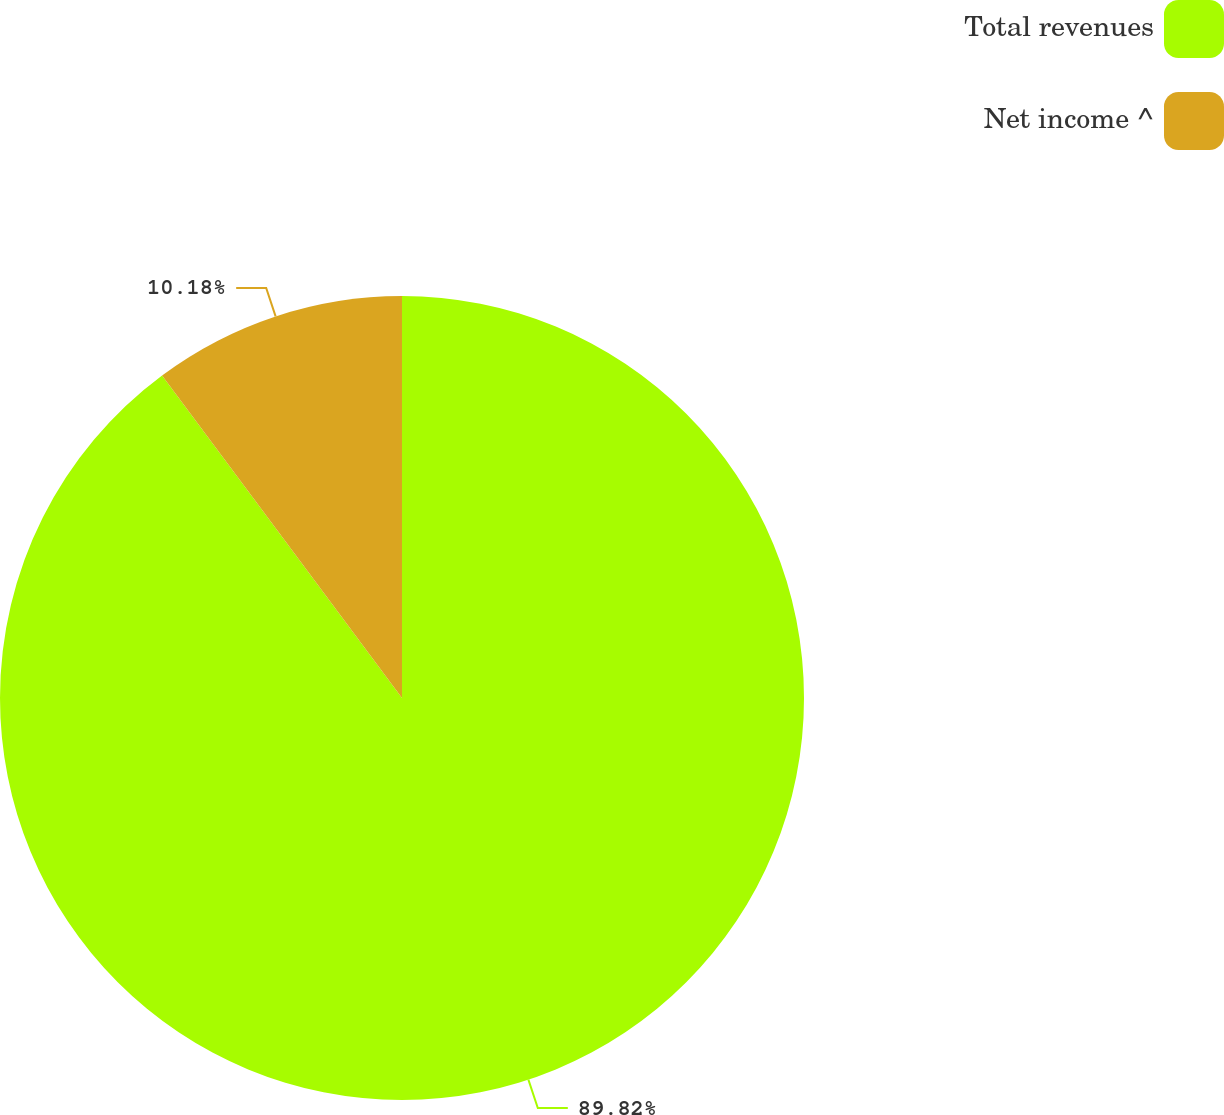Convert chart to OTSL. <chart><loc_0><loc_0><loc_500><loc_500><pie_chart><fcel>Total revenues<fcel>Net income ^<nl><fcel>89.82%<fcel>10.18%<nl></chart> 